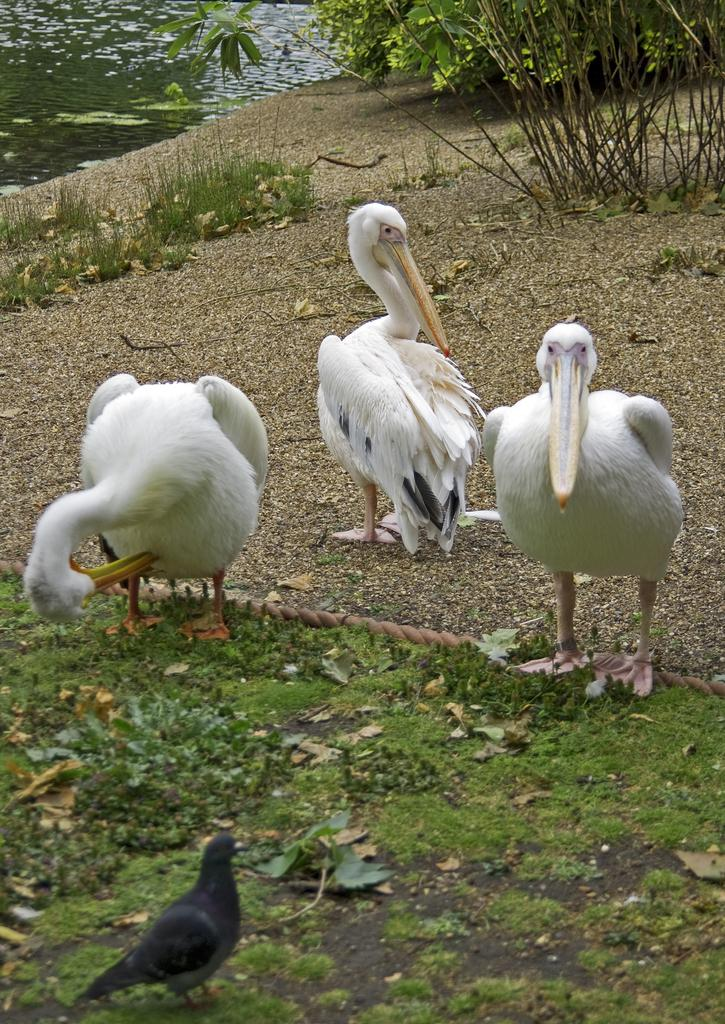What type of animals are on the ground in the image? There are birds on the ground in the image. What type of vegetation is present in the image? There is grass and plants in the image. What object can be seen in the image that is typically used for tying or securing? There is a rope in the image. What natural element is visible in the image? Water is visible in the image. What type of crime is being committed by the birds in the image? There is no crime being committed by the birds in the image; they are simply on the ground. 